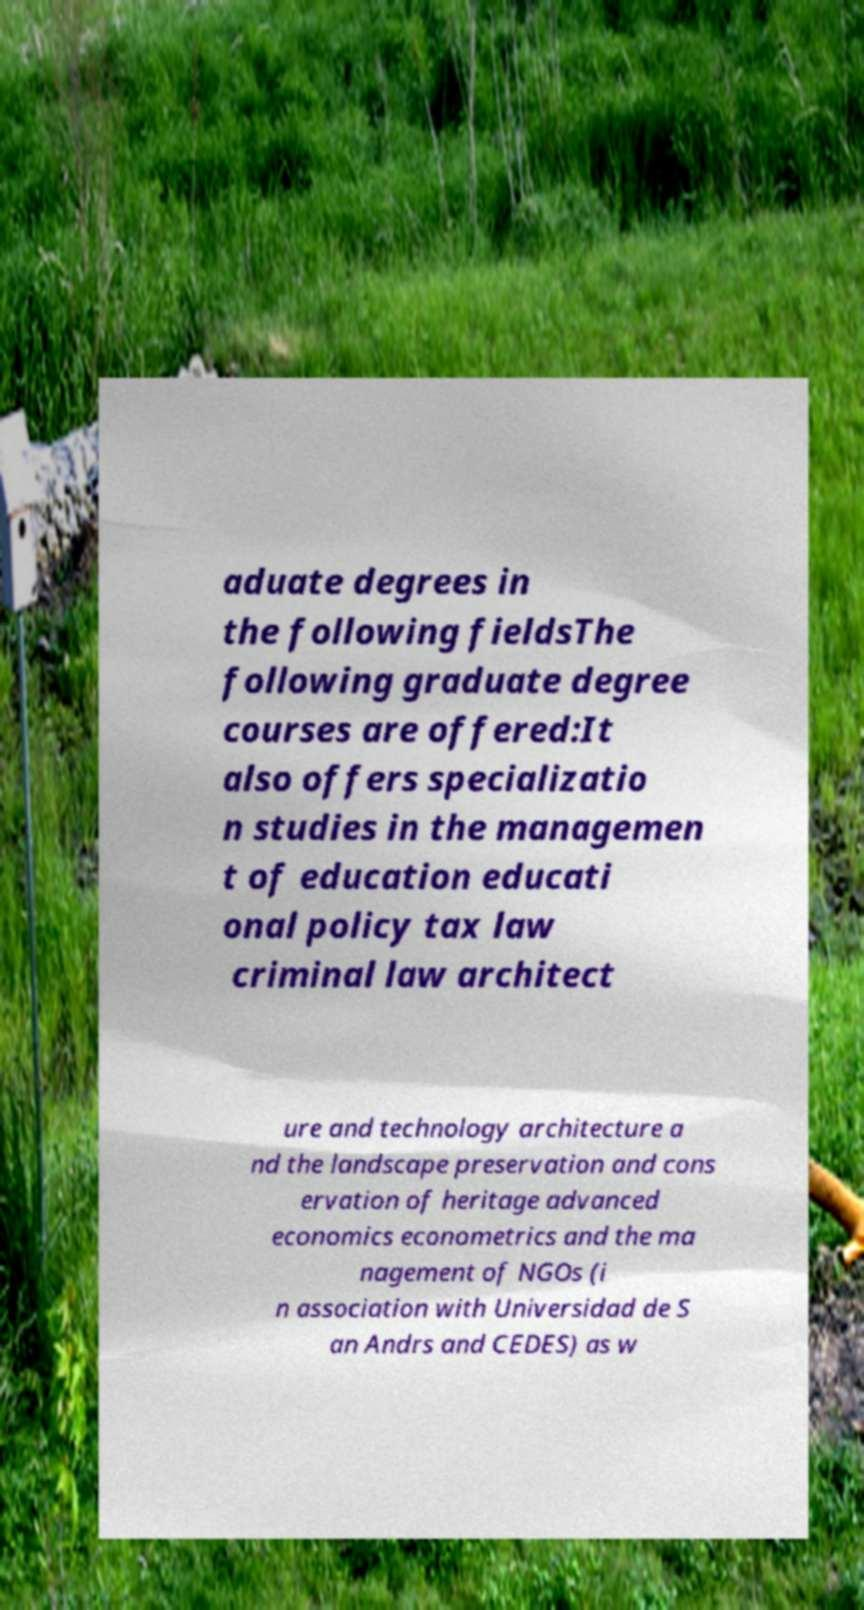Please identify and transcribe the text found in this image. aduate degrees in the following fieldsThe following graduate degree courses are offered:It also offers specializatio n studies in the managemen t of education educati onal policy tax law criminal law architect ure and technology architecture a nd the landscape preservation and cons ervation of heritage advanced economics econometrics and the ma nagement of NGOs (i n association with Universidad de S an Andrs and CEDES) as w 